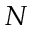<formula> <loc_0><loc_0><loc_500><loc_500>N</formula> 